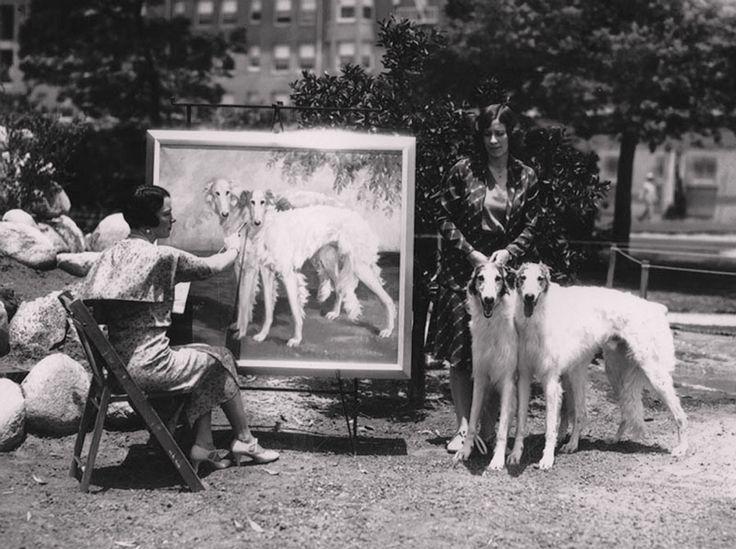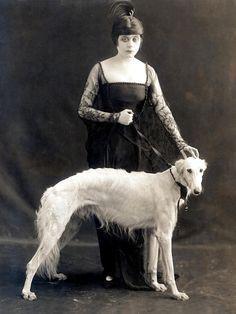The first image is the image on the left, the second image is the image on the right. Examine the images to the left and right. Is the description "A vintage image shows a woman in a non-floor-length skirt, jacket and hat standing outdoors next to one afghan hound." accurate? Answer yes or no. No. The first image is the image on the left, the second image is the image on the right. Considering the images on both sides, is "A woman is standing with a single dog in the image on the right." valid? Answer yes or no. Yes. 